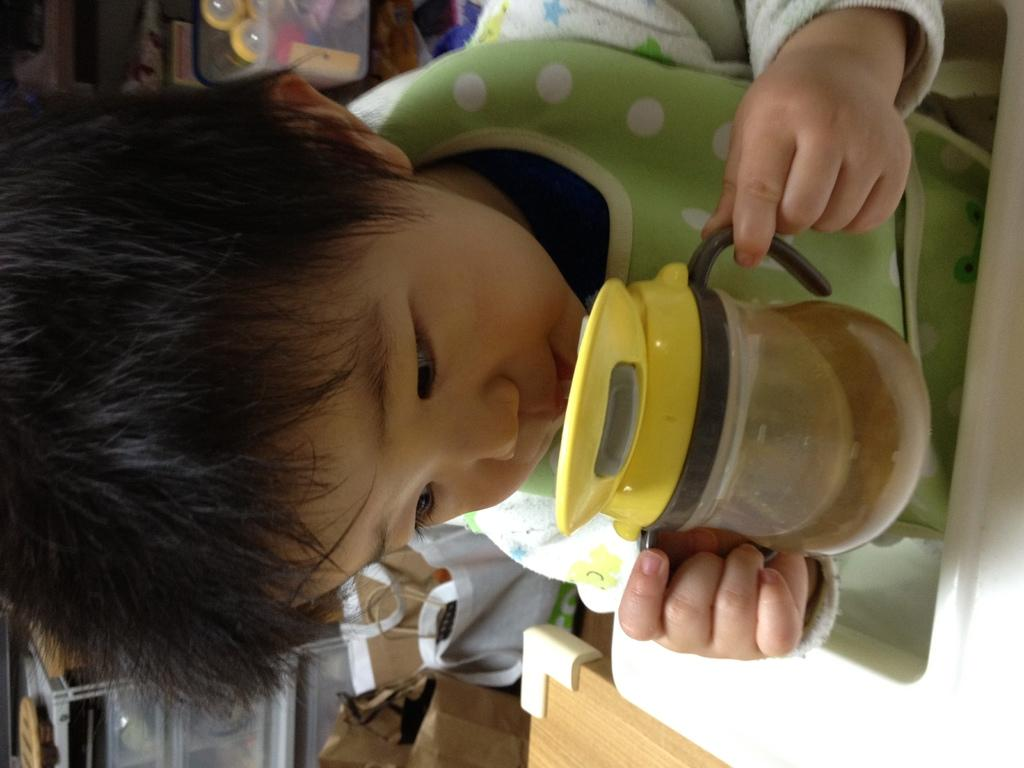What is the main subject of the image? There is a kid in the image. What is the kid doing in the image? The kid is drinking something and holding a bottle. What is the kid sitting or standing near? There is a table in the image. What can be seen behind the kid? There are packages behind the kid. What is inside the box in the image? There are objects in a box in the image. How many dogs are resting on the table in the image? There are no dogs present in the image, and therefore no dogs are resting on the table. What is the kid cooking in the image? There is no indication that the kid is cooking in the image. 